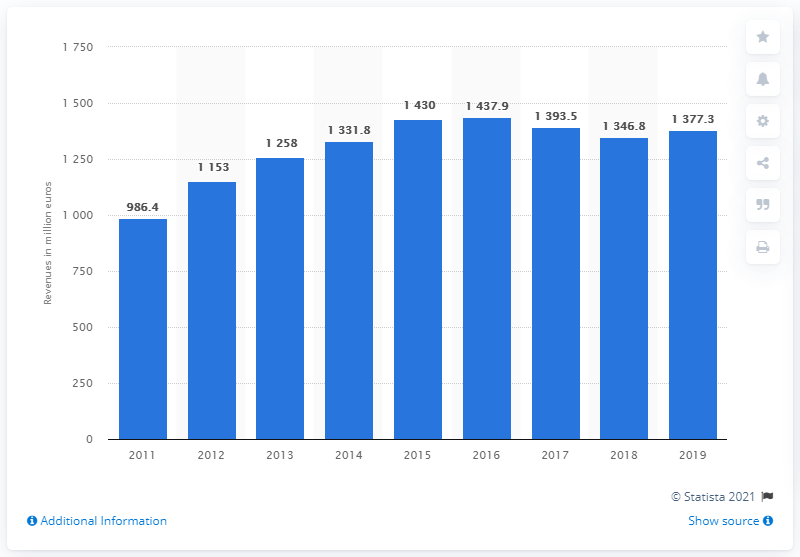Give some essential details in this illustration. In 2019, Salvatore Ferragamo's worldwide revenue was 1393.5 million US dollars. Ferragamo's worldwide revenue in 2016 was 1437.9 million dollars. Salvatore Ferragamo's overall revenue increased in 2011. 